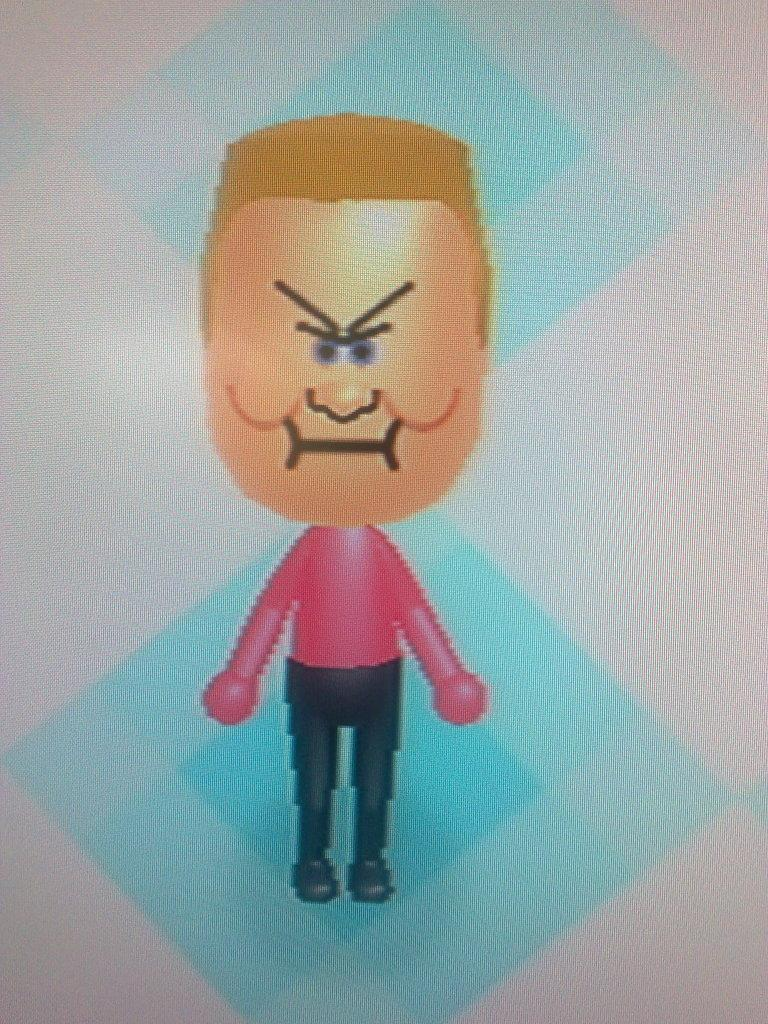What is the main subject of the image? There is a cartoon image of a person in the middle of the image. What reason does the cartoon person give for promoting peace in the image? There is no indication in the image that the cartoon person is promoting peace or providing a reason for doing so. 